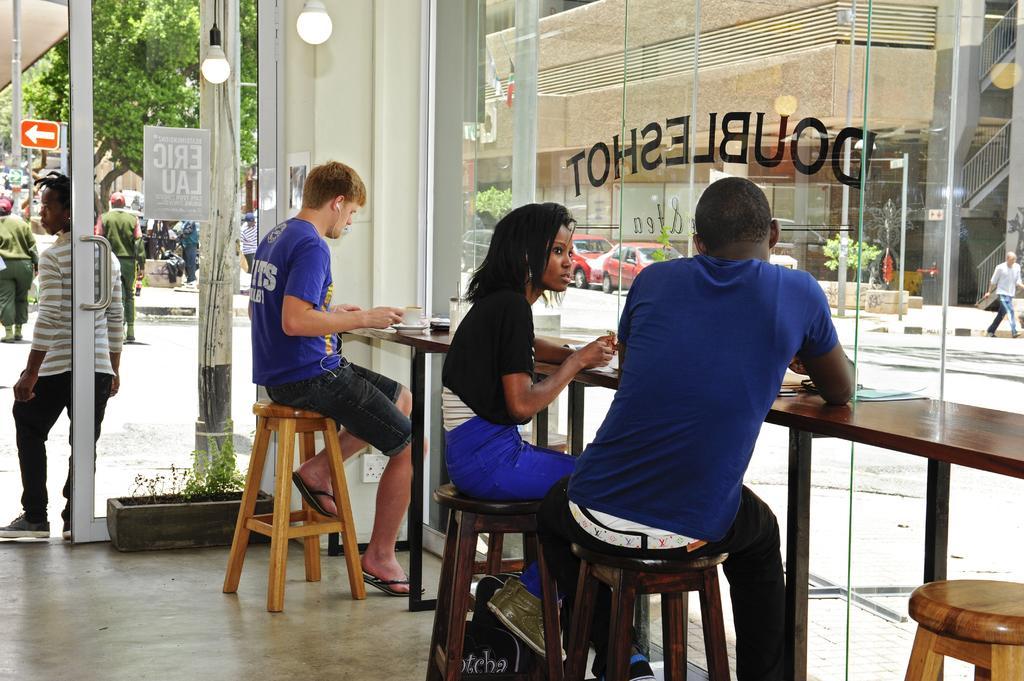Describe this image in one or two sentences. Person sitting on the stool,here there is glass,there is car another person sitting here another here,this person is standing,this is flower,person is wearing slippers,this are lights this is building,person walking here,here there is pole,here there is sign board,here there is tree. 